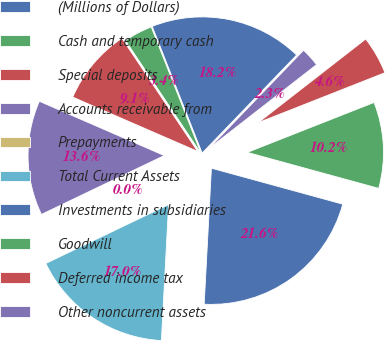Convert chart. <chart><loc_0><loc_0><loc_500><loc_500><pie_chart><fcel>(Millions of Dollars)<fcel>Cash and temporary cash<fcel>Special deposits<fcel>Accounts receivable from<fcel>Prepayments<fcel>Total Current Assets<fcel>Investments in subsidiaries<fcel>Goodwill<fcel>Deferred income tax<fcel>Other noncurrent assets<nl><fcel>18.18%<fcel>3.41%<fcel>9.09%<fcel>13.64%<fcel>0.0%<fcel>17.04%<fcel>21.59%<fcel>10.23%<fcel>4.55%<fcel>2.27%<nl></chart> 